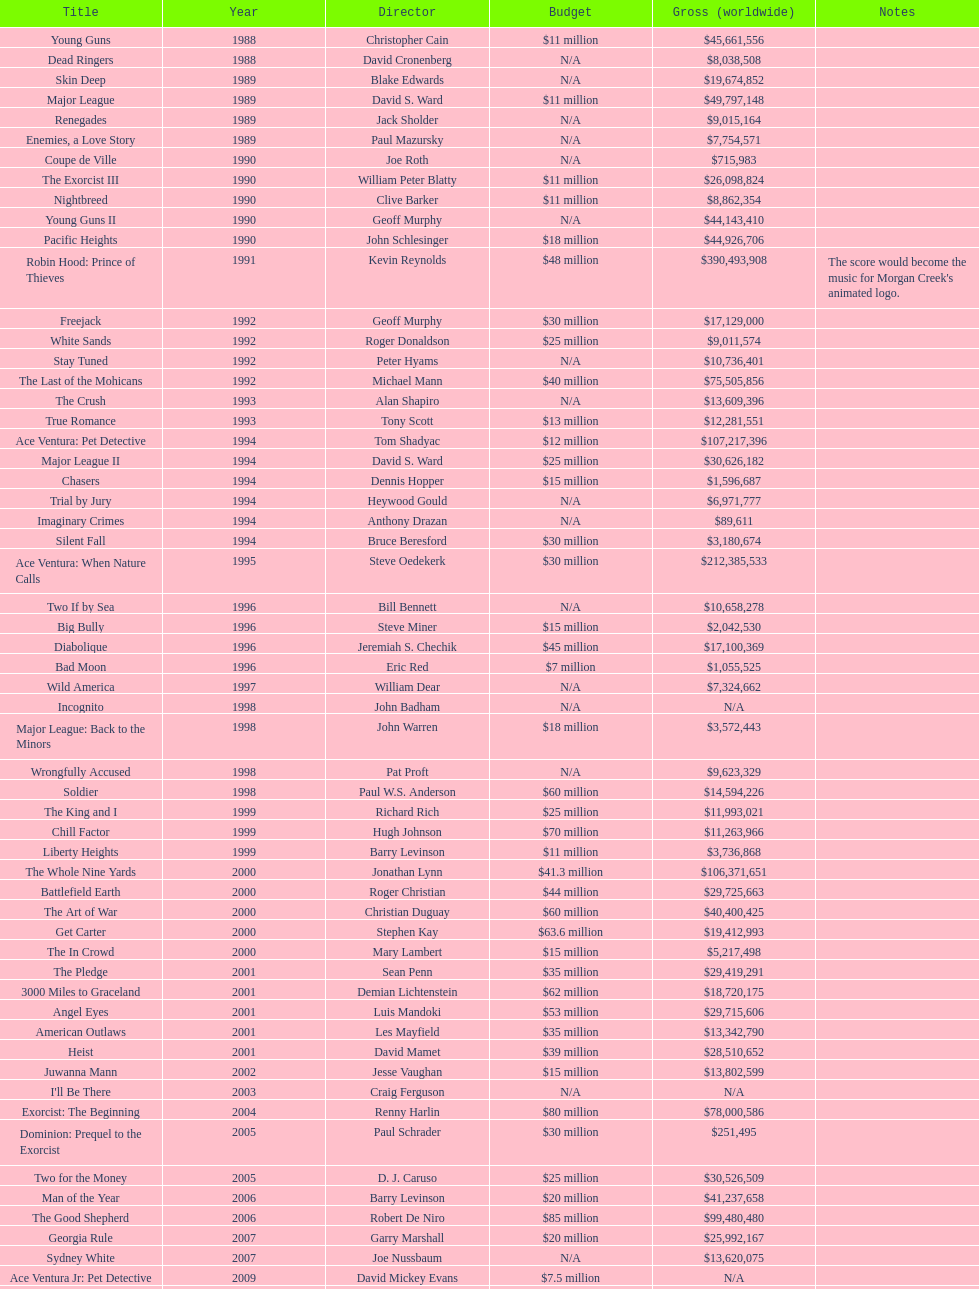How many films were there in 1990? 5. 